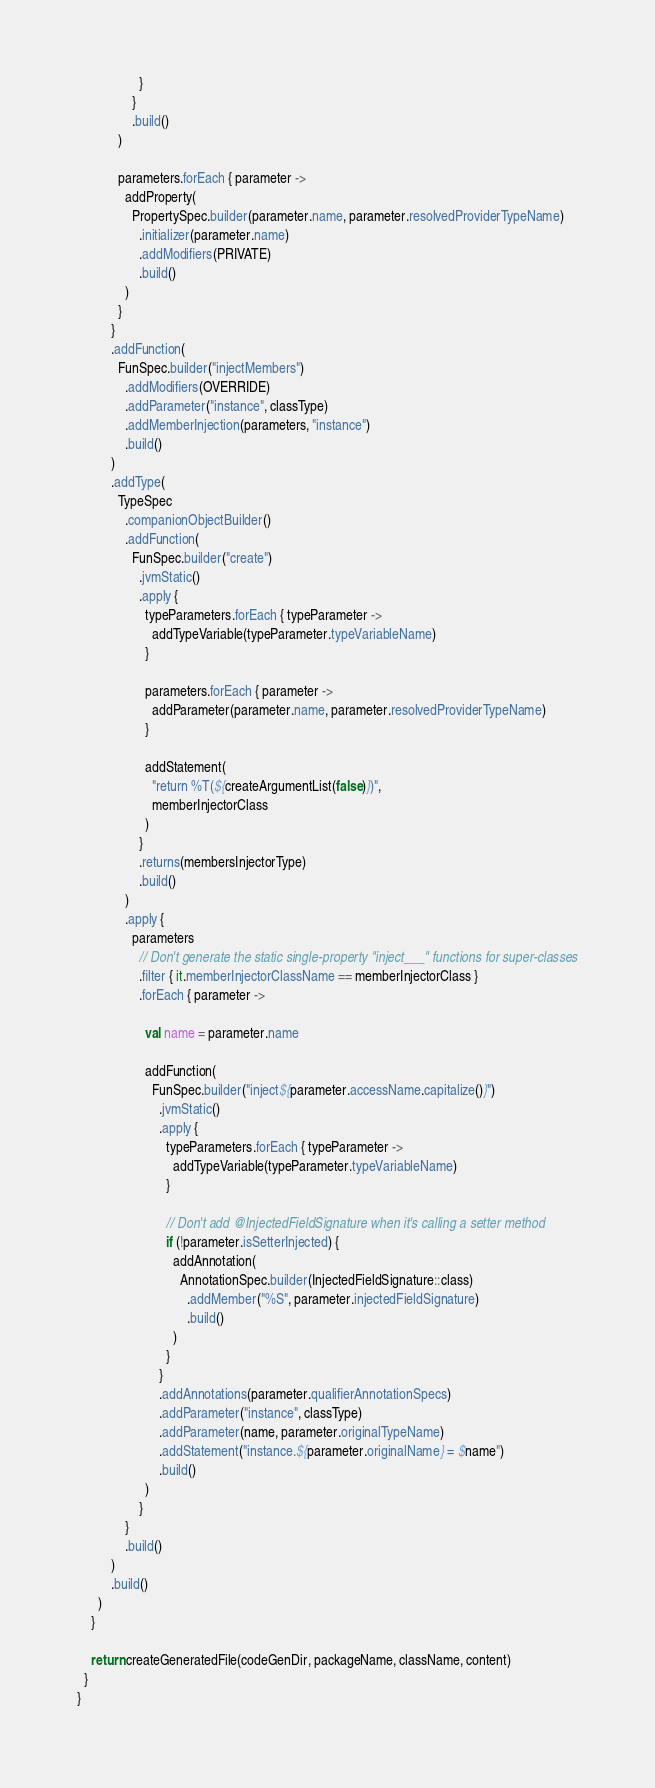<code> <loc_0><loc_0><loc_500><loc_500><_Kotlin_>                  }
                }
                .build()
            )

            parameters.forEach { parameter ->
              addProperty(
                PropertySpec.builder(parameter.name, parameter.resolvedProviderTypeName)
                  .initializer(parameter.name)
                  .addModifiers(PRIVATE)
                  .build()
              )
            }
          }
          .addFunction(
            FunSpec.builder("injectMembers")
              .addModifiers(OVERRIDE)
              .addParameter("instance", classType)
              .addMemberInjection(parameters, "instance")
              .build()
          )
          .addType(
            TypeSpec
              .companionObjectBuilder()
              .addFunction(
                FunSpec.builder("create")
                  .jvmStatic()
                  .apply {
                    typeParameters.forEach { typeParameter ->
                      addTypeVariable(typeParameter.typeVariableName)
                    }

                    parameters.forEach { parameter ->
                      addParameter(parameter.name, parameter.resolvedProviderTypeName)
                    }

                    addStatement(
                      "return %T(${createArgumentList(false)})",
                      memberInjectorClass
                    )
                  }
                  .returns(membersInjectorType)
                  .build()
              )
              .apply {
                parameters
                  // Don't generate the static single-property "inject___" functions for super-classes
                  .filter { it.memberInjectorClassName == memberInjectorClass }
                  .forEach { parameter ->

                    val name = parameter.name

                    addFunction(
                      FunSpec.builder("inject${parameter.accessName.capitalize()}")
                        .jvmStatic()
                        .apply {
                          typeParameters.forEach { typeParameter ->
                            addTypeVariable(typeParameter.typeVariableName)
                          }

                          // Don't add @InjectedFieldSignature when it's calling a setter method
                          if (!parameter.isSetterInjected) {
                            addAnnotation(
                              AnnotationSpec.builder(InjectedFieldSignature::class)
                                .addMember("%S", parameter.injectedFieldSignature)
                                .build()
                            )
                          }
                        }
                        .addAnnotations(parameter.qualifierAnnotationSpecs)
                        .addParameter("instance", classType)
                        .addParameter(name, parameter.originalTypeName)
                        .addStatement("instance.${parameter.originalName} = $name")
                        .build()
                    )
                  }
              }
              .build()
          )
          .build()
      )
    }

    return createGeneratedFile(codeGenDir, packageName, className, content)
  }
}
</code> 